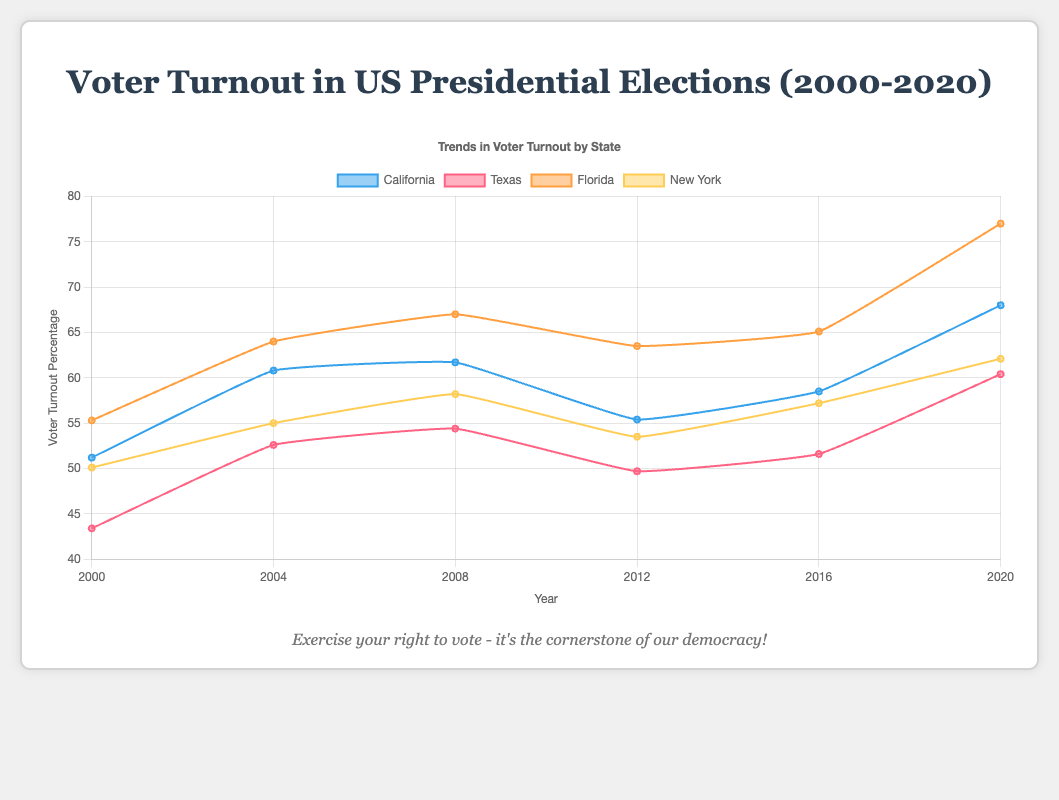What is the voter turnout percentage for Texas in 2008? Locate the data line for Texas on the plot. Follow it to the year 2008 and read the corresponding percentage value.
Answer: 54.4% Which state had the highest voter turnout in 2020? Observe the voter turnout percentages for all states in the year 2020. Identify the highest value among these.
Answer: Florida Did California's voter turnout increase or decrease from 2000 to 2020? Look at the voter turnout values for California in 2000 and compare them with 2020. If the later year has a higher percentage, it increased; otherwise, it decreased.
Answer: Increase Compare the voter turnout between Texas and New York in 2012. Which state had a higher voter turnout? Find the voter turnout percentages for Texas and New York in the year 2012. Compare these two values to determine which one is higher.
Answer: Texas Which state shows the most significant increase in voter turnout from 2016 to 2020? Calculate the differences in voter turnout percentages for all states between 2016 and 2020. Identify the state with the largest difference.
Answer: Florida What is the average voter turnout percentage in California across all years? Sum the voter turnout percentages for California from 2000 to 2020 and then divide by the number of years (6).
Answer: 59.27% Which state experienced a decrease in voter turnout from 2008 to 2012? Look at the voter turnout percentages for each state in 2008 and 2012. Identify any state where the percentage in 2012 is lower than in 2008.
Answer: Texas, New York, California, Florida Is the voter turnout trend in Florida generally increasing, decreasing, or fluctuating over the years from 2000 to 2020? Examine Florida's voter turnout percentages year by year to see if there's a consistent increase, decrease, or fluctuating pattern.
Answer: Increasing Between California and New York, which state had a higher voter turnout percentage in 2004? Check the voter turnout percentages for both California and New York in 2004 and compare them.
Answer: California 